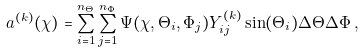<formula> <loc_0><loc_0><loc_500><loc_500>a ^ { ( k ) } ( \chi ) = \sum _ { i = 1 } ^ { n _ { \Theta } } \sum _ { j = 1 } ^ { n _ { \Phi } } \Psi ( \chi , \Theta _ { i } , \Phi _ { j } ) Y ^ { ( k ) } _ { i j } \sin ( \Theta _ { i } ) \Delta \Theta \Delta \Phi \, ,</formula> 